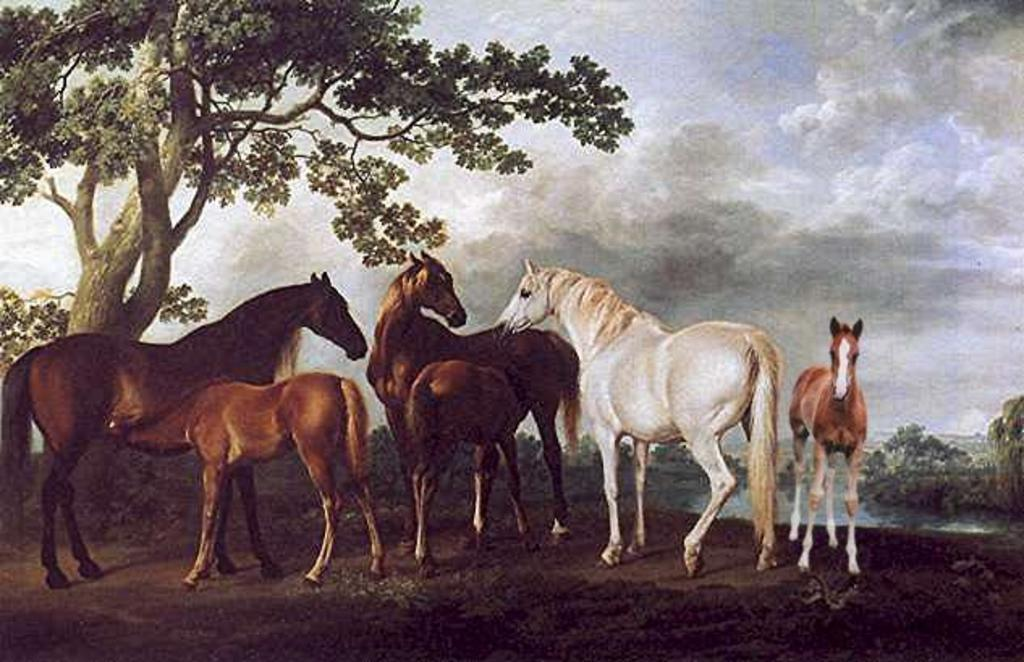What animals are present in the image? There are horses in the image. What colors can be seen on the horses? The horses are in brown and white colors. What is located on the left side of the image? There is a tree on the left side of the image. What can be seen in the sky in the background of the image? There are clouds in the sky in the background of the image. What type of skin treatment is being applied to the horses in the image? There is no indication in the image that the horses are receiving any skin treatment. 